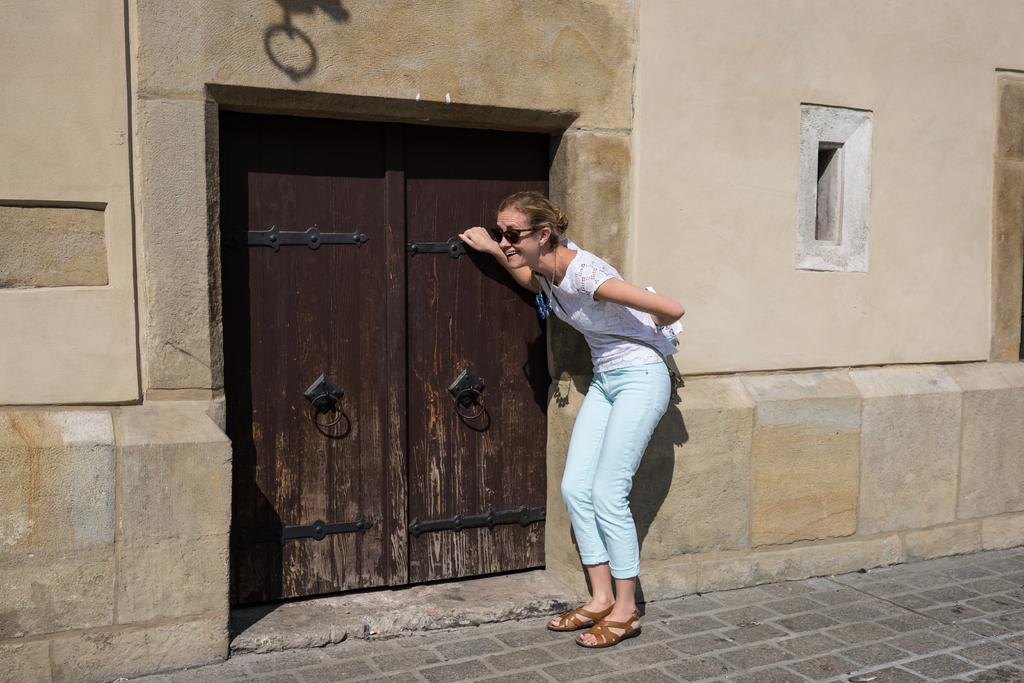What is happening in the image involving a person? The person in the image is knocking on a door. What is the person holding in the image? The person is holding an object. What can be seen on the wall in the image? There are objects visible on the wall in the image. What is visible beneath the person in the image? The ground is visible in the image. What type of mitten is the person wearing in the image? The person is not wearing a mitten in the image; they are holding an object while knocking on a door. How is the spade being used in the image? There is no spade present in the image. 